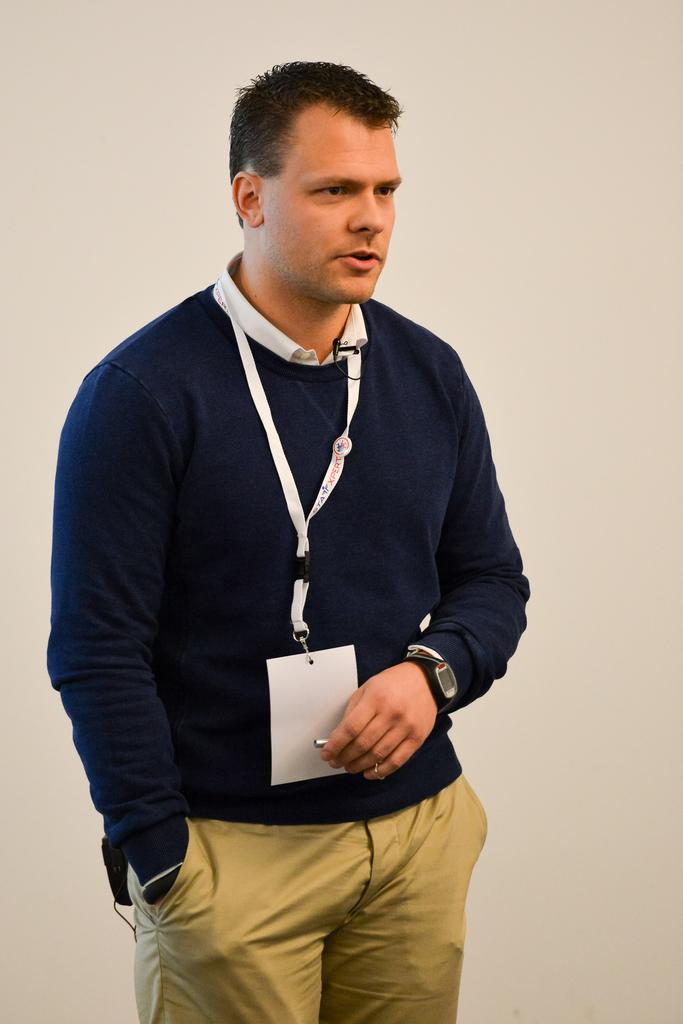Who or what is the main subject in the image? There is a person in the image. What is the person wearing in the image? The person is wearing an ID card. What can be seen in the background of the image? There is a wall in the background of the image. What type of fruit is hanging from the curtain in the image? There is no fruit or curtain present in the image. Can you see a bridge in the background of the image? No, there is no bridge visible in the image; only a wall is present in the background. 